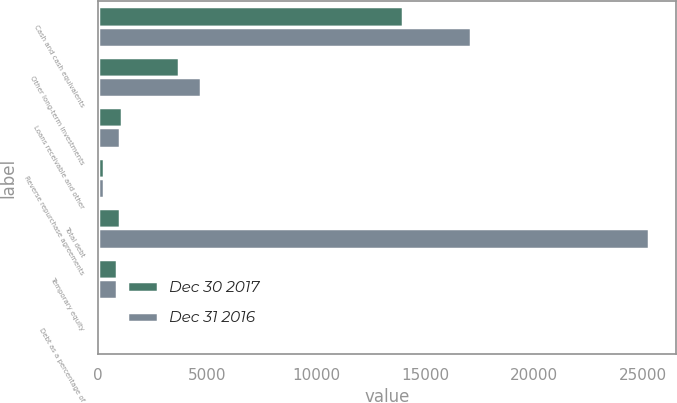<chart> <loc_0><loc_0><loc_500><loc_500><stacked_bar_chart><ecel><fcel>Cash and cash equivalents<fcel>Other long-term investments<fcel>Loans receivable and other<fcel>Reverse repurchase agreements<fcel>Total debt<fcel>Temporary equity<fcel>Debt as a percentage of<nl><fcel>Dec 30 2017<fcel>14002<fcel>3712<fcel>1097<fcel>250<fcel>996<fcel>866<fcel>38.8<nl><fcel>Dec 31 2016<fcel>17099<fcel>4716<fcel>996<fcel>250<fcel>25283<fcel>882<fcel>38.2<nl></chart> 